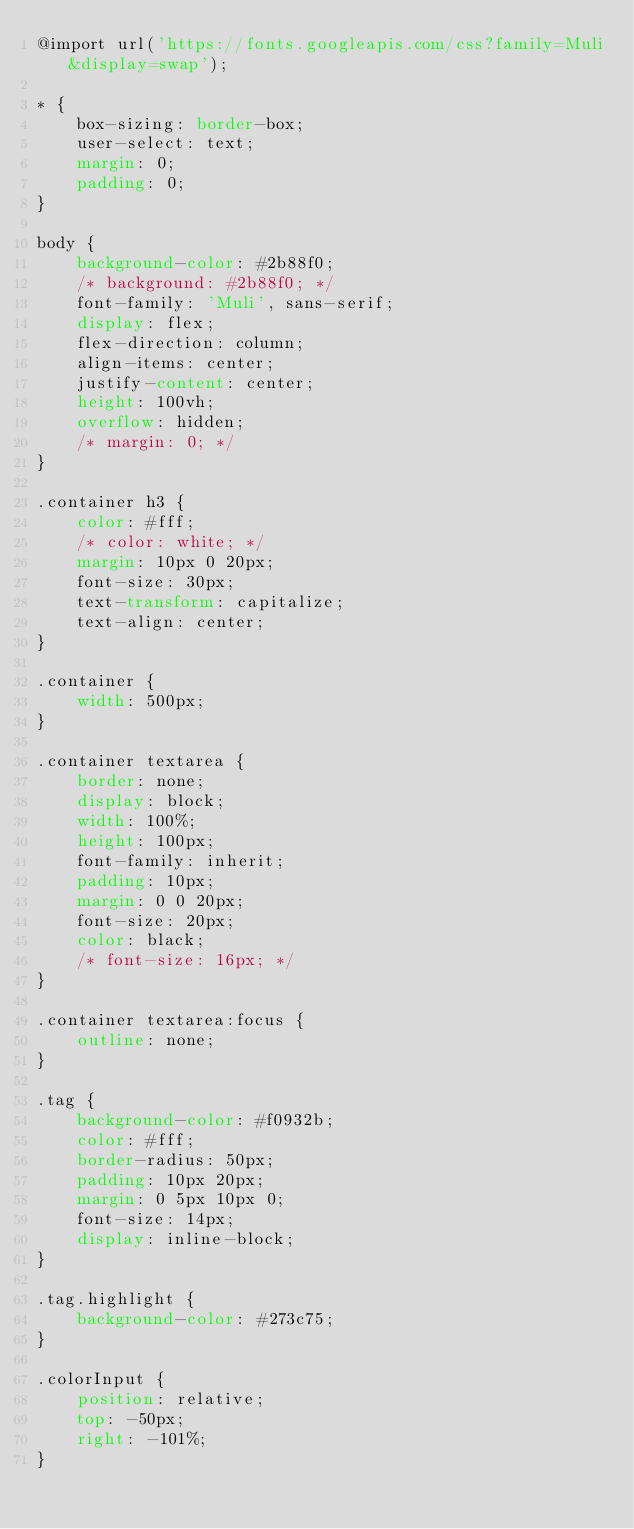<code> <loc_0><loc_0><loc_500><loc_500><_CSS_>@import url('https://fonts.googleapis.com/css?family=Muli&display=swap');

* {
    box-sizing: border-box;
    user-select: text;
    margin: 0;
    padding: 0;
}

body {
    background-color: #2b88f0;
    /* background: #2b88f0; */
    font-family: 'Muli', sans-serif;
    display: flex;
    flex-direction: column;
    align-items: center;
    justify-content: center;
    height: 100vh;
    overflow: hidden;
    /* margin: 0; */
}

.container h3 {
    color: #fff;
    /* color: white; */
    margin: 10px 0 20px;
    font-size: 30px;
    text-transform: capitalize;
    text-align: center;
}

.container {
    width: 500px;
}

.container textarea {
    border: none;
    display: block;
    width: 100%;
    height: 100px;
    font-family: inherit;
    padding: 10px;
    margin: 0 0 20px;
    font-size: 20px;
    color: black;
    /* font-size: 16px; */
}

.container textarea:focus {
    outline: none;
}

.tag {
    background-color: #f0932b;
    color: #fff;
    border-radius: 50px;
    padding: 10px 20px;
    margin: 0 5px 10px 0;
    font-size: 14px;
    display: inline-block;
}

.tag.highlight {
    background-color: #273c75;
}

.colorInput {
    position: relative;
    top: -50px;
    right: -101%;
}</code> 